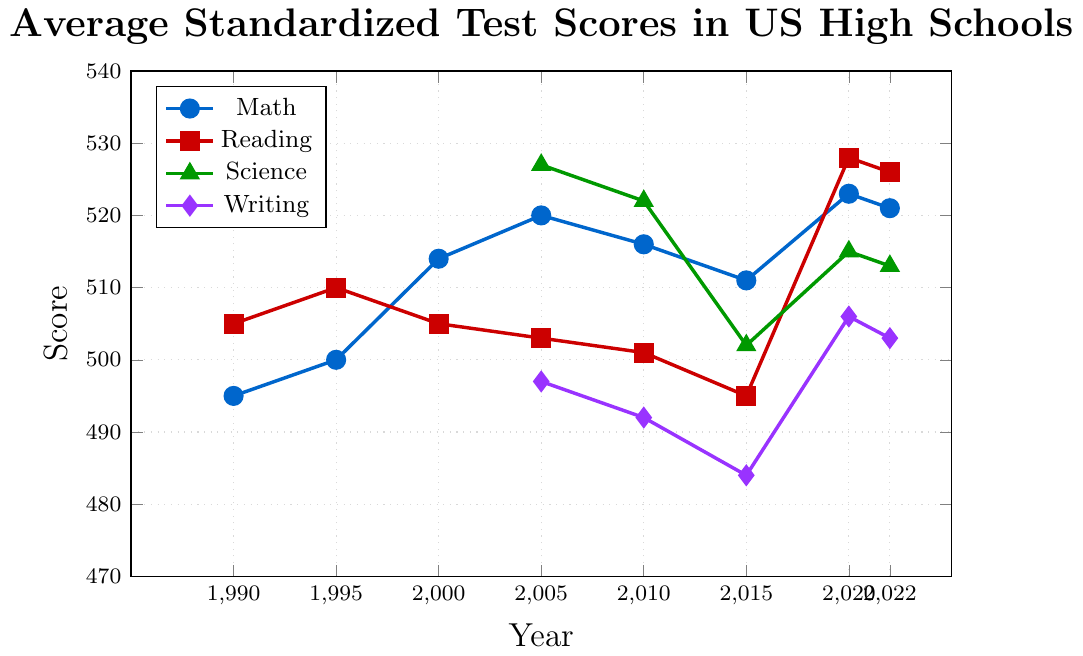what was the average math score from 1990 to 2022? To find the average math score from 1990 to 2022, sum the scores (495 + 500 + 514 + 520 + 516 + 511 + 523 + 521) and divide by the number of years (8). The sum is 4100 and the average is 4100/8.
Answer: 512.5 which subject had the highest score in 2020? In the year 2020, the scores for each subject were Math: 523, Reading: 528, Science: 515, Writing: 506. The highest score is in Reading.
Answer: Reading what is the trend of math scores from 2010 to 2022? From 2010 to 2022, the math scores are 516, 511, 523, and 521. The score initially decreases from 516 to 511, then increases to 523, and slightly decreases again to 521.
Answer: Decreasing initially, then increasing find the difference between the highest and lowest science scores The highest science score is 527 and the lowest is 502, so the difference is 527 - 502.
Answer: 25 compare the reading scores in 1990 and 2015; which was higher? The reading score in 1990 was 505, and in 2015 it was 495. Hence, the score in 1990 was higher.
Answer: 1990 how did the writing score change from 2005 to 2022? The writing scores were 497 in 2005 and 503 in 2022. This indicates that the score increased by 503 - 497.
Answer: 6 which subject showed the most improvement from its lowest to highest scores? Calculating score differences: Math: 523 - 495 = 28, Reading: 528 - 495 = 33, Science: 527 - 502 = 25, Writing: 506 - 484 = 22. The subject that showed the most improvement is Reading with a score increase of 33.
Answer: Reading what was the science score trend from 2005 to 2022? The science scores over this period were 527, 522, 502, 515, and 513. The trend shows an initial decrease from 527 to 502, then an increase to 515, followed by a slight decrease again to 513.
Answer: Decreasing then increasing what is the lowest average score across all years and subjects? To find the lowest average score, calculate the sum of scores for each subject and divide by the number of scores. Math: (495+500+514+520+516+511+523+521)/8 = 512.5, Reading: (505+510+505+503+501+495+528+526)/8 = 509.1, Science: (527+522+502+515+513)/5 = 515.8, Writing: (497+492+484+506+503)/5 = 496.4. The lowest average score across all subjects is in Writing.
Answer: Writing 